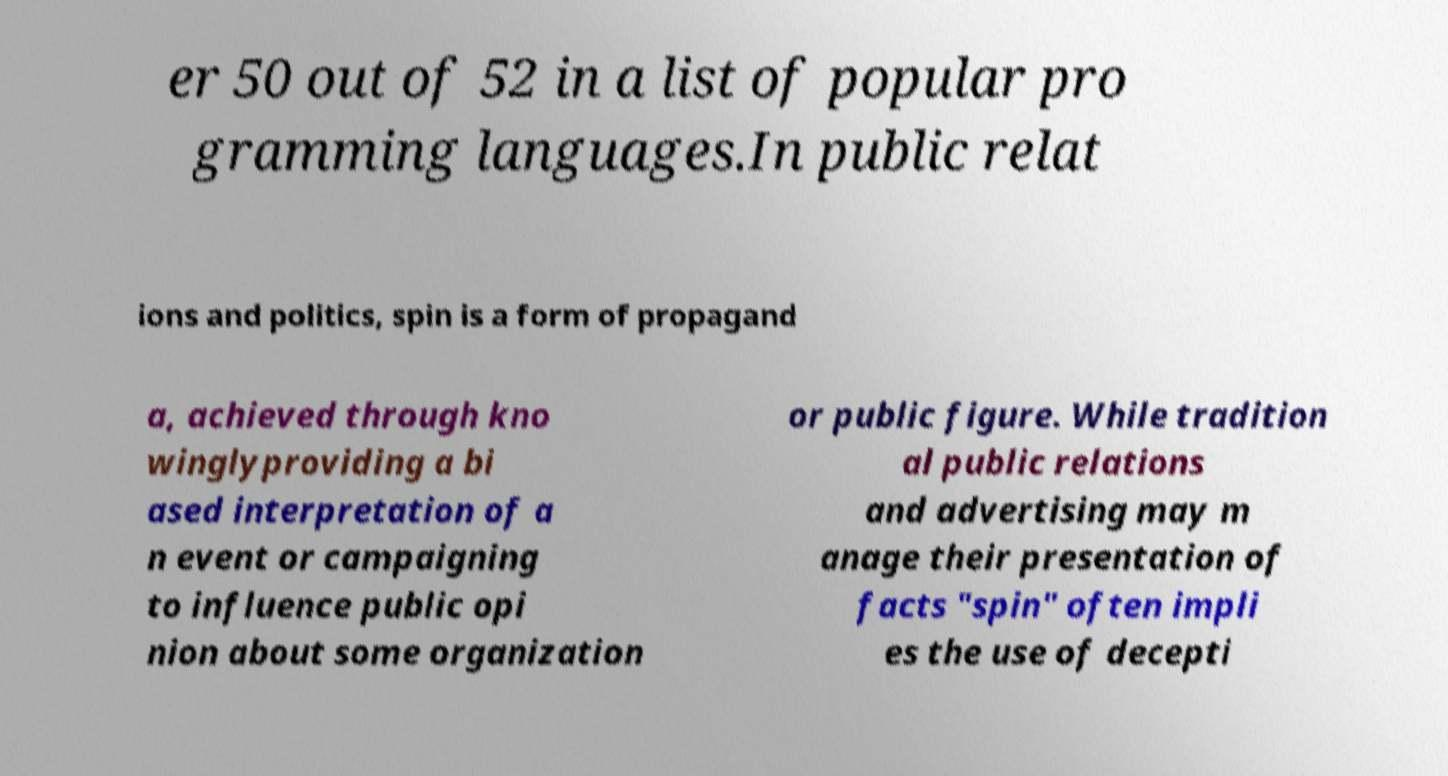What messages or text are displayed in this image? I need them in a readable, typed format. er 50 out of 52 in a list of popular pro gramming languages.In public relat ions and politics, spin is a form of propagand a, achieved through kno winglyproviding a bi ased interpretation of a n event or campaigning to influence public opi nion about some organization or public figure. While tradition al public relations and advertising may m anage their presentation of facts "spin" often impli es the use of decepti 